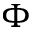Convert formula to latex. <formula><loc_0><loc_0><loc_500><loc_500>\Phi</formula> 